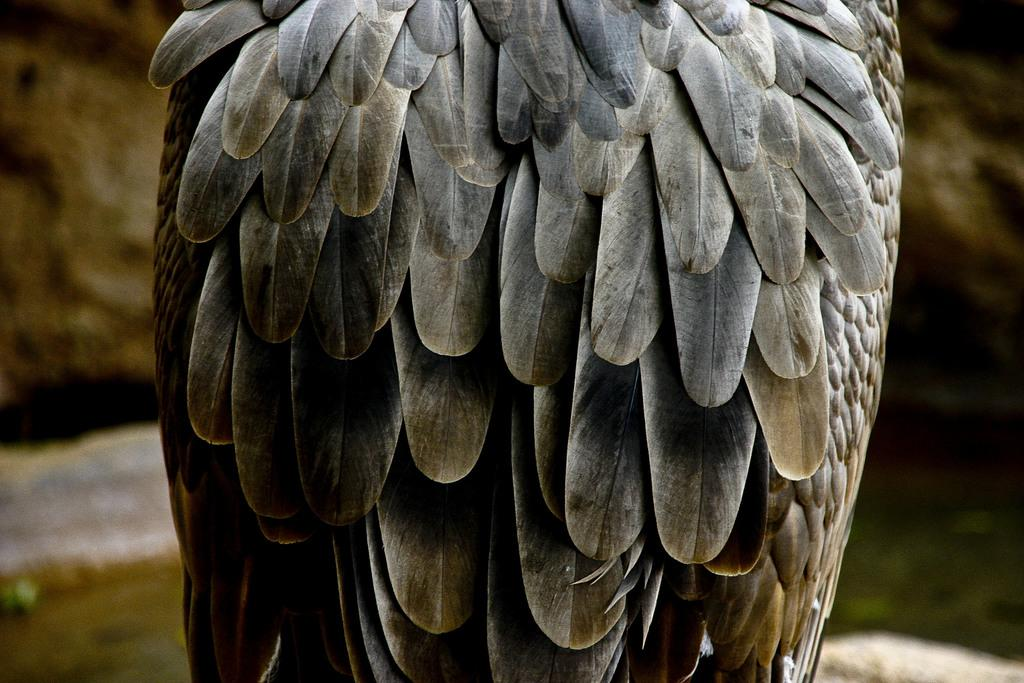What type of animal is present in the image? There is a bird in the image. What color is the background of the image? The background of the image is blue. How does the bird use the comb in the image? There is no comb present in the image; it only features a bird and a blue background. 